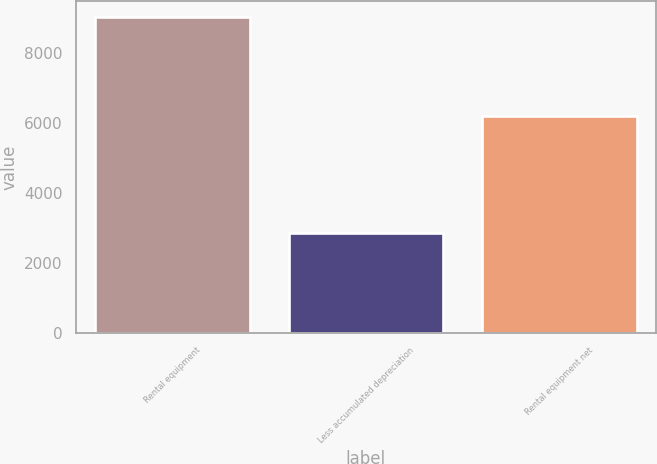<chart> <loc_0><loc_0><loc_500><loc_500><bar_chart><fcel>Rental equipment<fcel>Less accumulated depreciation<fcel>Rental equipment net<nl><fcel>9022<fcel>2836<fcel>6186<nl></chart> 